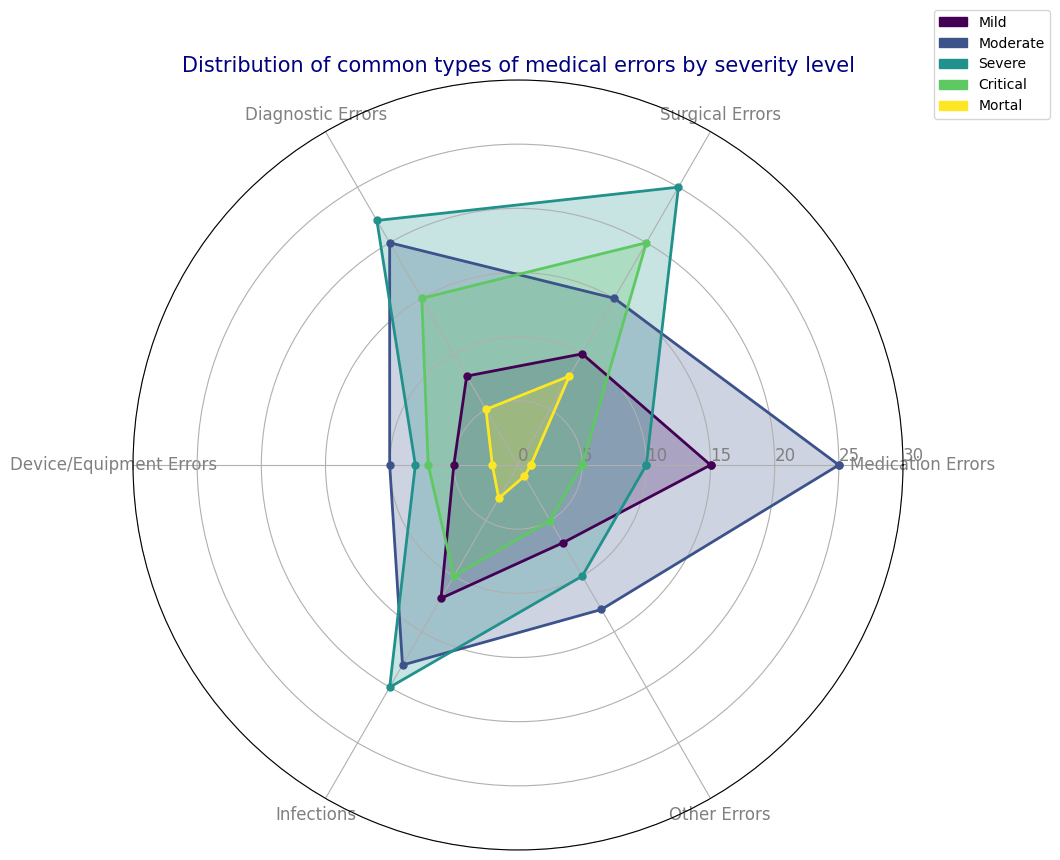What is the most common type of error in the "Severe" category? Look at the "Severe" category's plot and identify the error type with the highest value. Surgical Errors have the highest value (25) in this category.
Answer: Surgical Errors Which severity level has the highest number of Medication Errors? Compare the plotted values for Medication Errors across all severity levels. The "Moderate" severity level has the highest value (25) for Medication Errors.
Answer: Moderate What is the total number of errors for the "Mild" category? Add all the error values for the "Mild" category: 15 (Medication) + 10 (Surgical) + 8 (Diagnostic) + 5 (Device/Equipment) + 12 (Infections) + 7 (Other) = 57.
Answer: 57 How do Device/Equipment Errors compare between the "Critical" and "Mortal" categories? Compare the plotted values for Device/Equipment Errors between these two categories. The "Critical" category has 7 Device/Equipment Errors, while the "Mortal" category has 2. 7 is greater than 2.
Answer: Critical has more Which category has the closest number of Diagnostic Errors to 10? Look at the values plotted for Diagnostic Errors and find the one closest to 10. The "Critical" category has 15, the closest to 10.
Answer: Critical Which severity level has the lowest total number of errors? Sum the error values for each severity category, then find the lowest sum. "Mortal" has the lowest total: 1 (Medication) + 8 (Surgical) + 5 (Diagnostic) + 2 (Device/Equipment) + 3 (Infections) + 1 (Other) = 20.
Answer: Mortal What is the average number of errors for Surgical Errors and Infections in the "Moderate" category? Sum the values for Surgical Errors (15) and Infections (18), then divide by 2 to find the average: (15 + 18) / 2 = 16.5.
Answer: 16.5 Are there more Device/Equipment Errors or Other Errors in the "Severe" category? Compare the plotted values for Device/Equipment Errors (8) and Other Errors (10) in the "Severe" category. Other Errors have a higher value than Device/Equipment Errors.
Answer: Other Errors What is the difference between the number of Surgical Errors in the "Critical" and "Severe" categories? Subtract the number of Surgical Errors in the "Critical" category (20) from that in the "Severe" category (25): 25 - 20 = 5.
Answer: 5 Which category shows a consistent decrease in errors from "Mild" to "Mortal" severity levels? Examine the trend for each error category across all severity levels to identify a consistently decreasing pattern. Medication Errors show a consistent decrease: 15 (Mild), 25 (Moderate), 10 (Severe), 5 (Critical), 1 (Mortal).
Answer: Medication Errors 